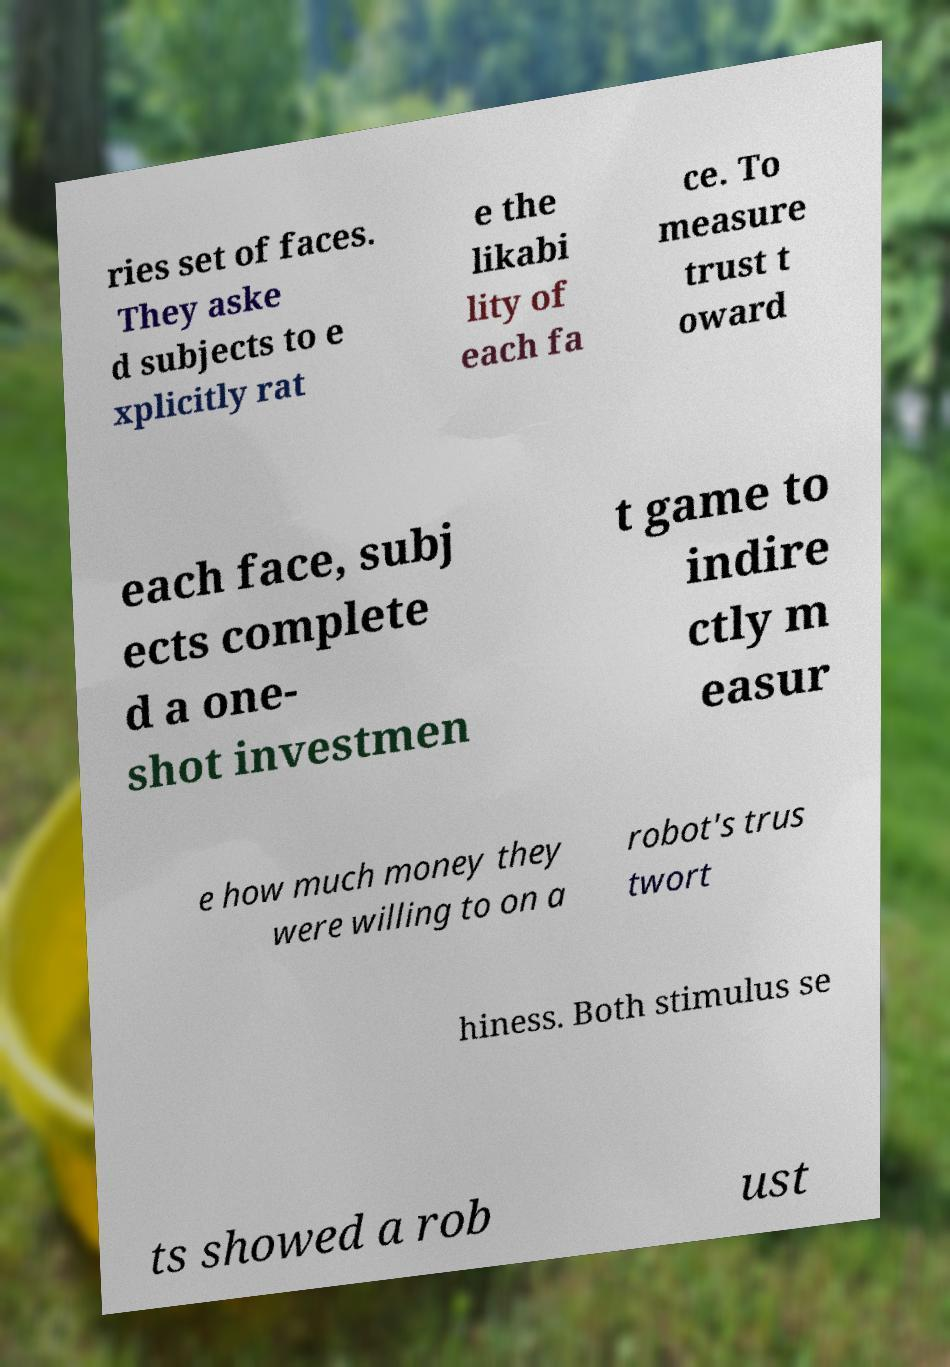Could you extract and type out the text from this image? ries set of faces. They aske d subjects to e xplicitly rat e the likabi lity of each fa ce. To measure trust t oward each face, subj ects complete d a one- shot investmen t game to indire ctly m easur e how much money they were willing to on a robot's trus twort hiness. Both stimulus se ts showed a rob ust 